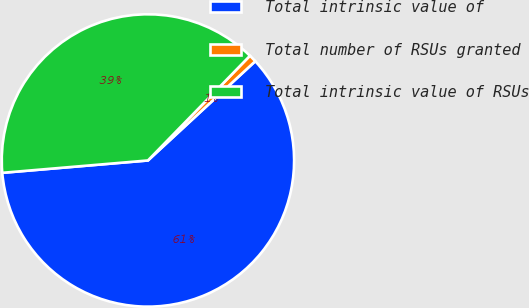Convert chart. <chart><loc_0><loc_0><loc_500><loc_500><pie_chart><fcel>Total intrinsic value of<fcel>Total number of RSUs granted<fcel>Total intrinsic value of RSUs<nl><fcel>60.53%<fcel>0.83%<fcel>38.64%<nl></chart> 